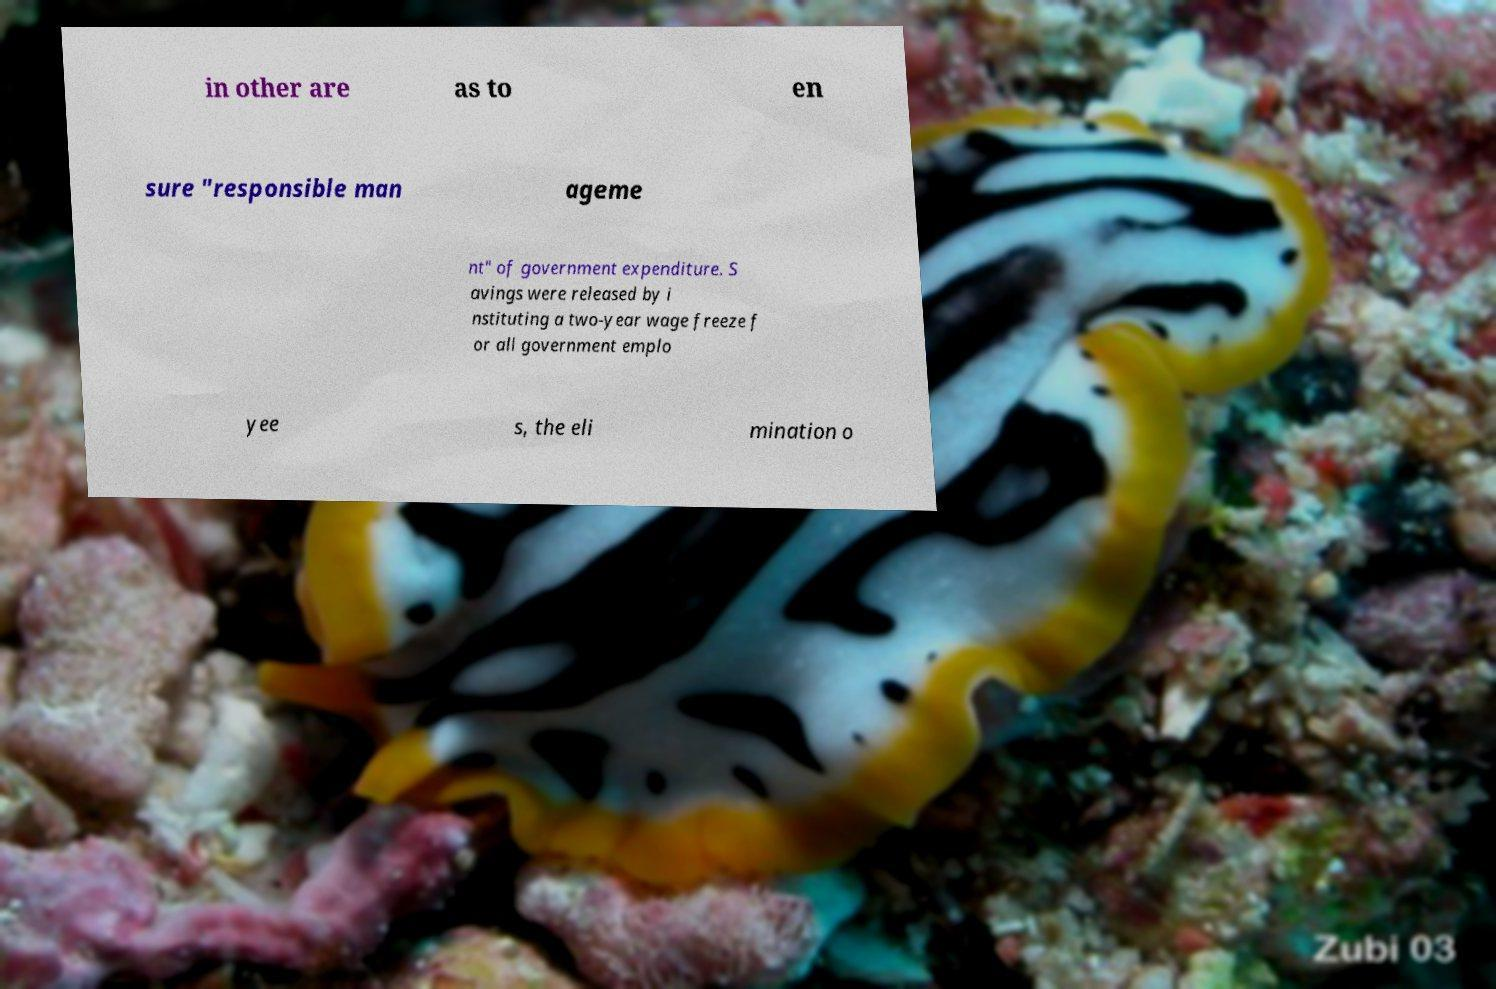Could you extract and type out the text from this image? in other are as to en sure "responsible man ageme nt" of government expenditure. S avings were released by i nstituting a two-year wage freeze f or all government emplo yee s, the eli mination o 